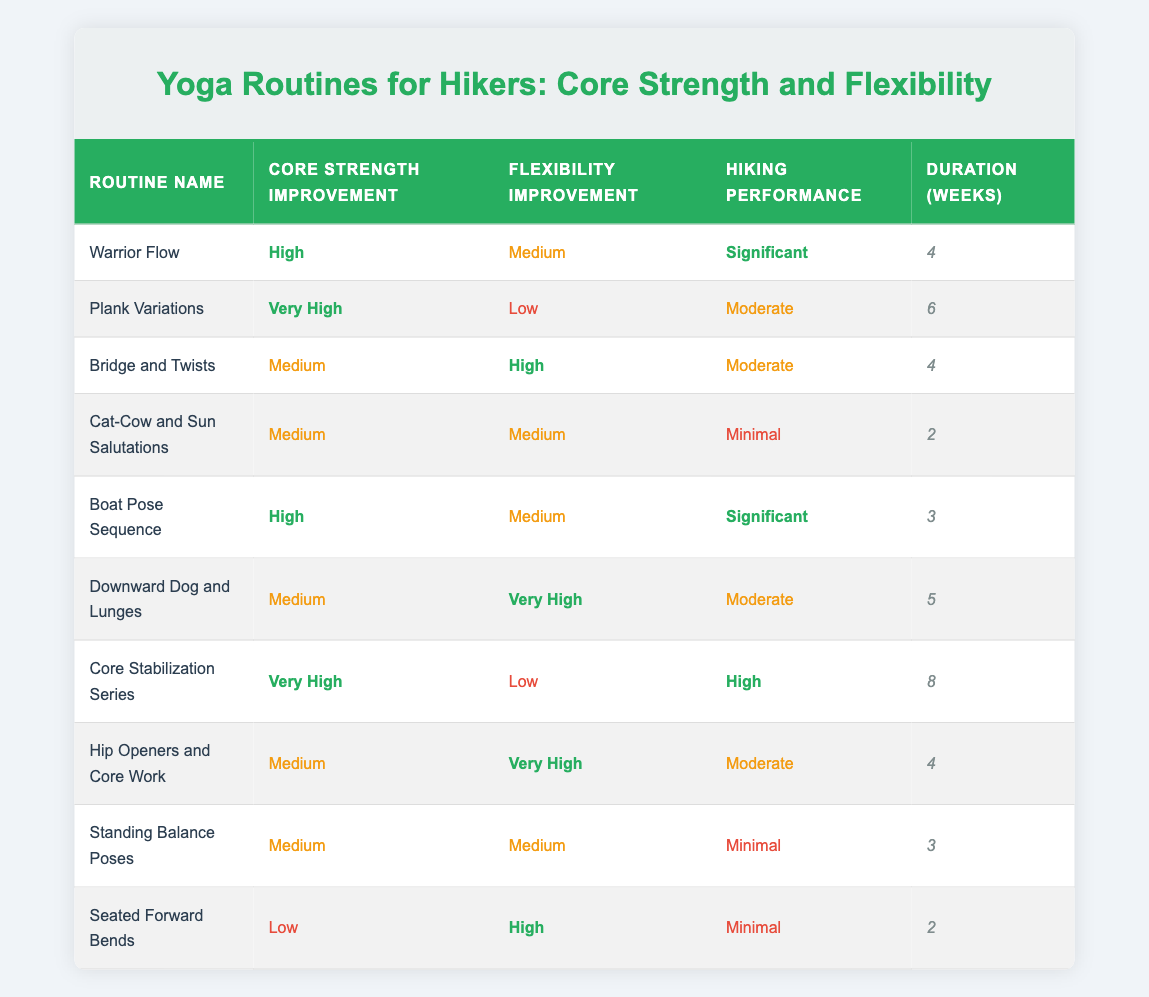What yoga routine has the highest core strength improvement? The table shows the yoga routines sorted by their core strength improvement ratings. The routine "Plank Variations" has a core strength improvement rated as "Very High," which is the highest among all routines listed.
Answer: Plank Variations How many weeks does the "Core Stabilization Series" last? The "Core Stabilization Series" routine's duration is explicitly listed in the table as 8 weeks.
Answer: 8 Is the hiking performance of "Cat-Cow and Sun Salutations" significant? Looking at the hiking performance column, "Cat-Cow and Sun Salutations" is indicated as "Minimal," meaning this routine does not lead to significant hiking performance improvements.
Answer: No Which routine offers medium flexibility improvement and high core strength improvement? By filtering the table for routines that have "Medium" flexibility improvement and "High" core strength improvement, we find "Warrior Flow" and "Boat Pose Sequence." Thus, there are two potential routines that meet these criteria.
Answer: Warrior Flow, Boat Pose Sequence What is the average duration of the yoga routines listed? To find the average duration, we sum the durations: (4 + 6 + 4 + 2 + 3 + 5 + 8 + 4 + 3 + 2) = 41 weeks. Then we divide this by the number of routines, which is 10. The average duration is 41/10 = 4.1 weeks.
Answer: 4.1 weeks Do any routines have both very high core strength improvement and very high flexibility improvement? By reviewing the table, no routine has both "Very High" in core strength improvement and "Very High" in flexibility improvement simultaneously, thus confirming there are none.
Answer: No Which routine contributes more significantly to hiking performance: "Core Stabilization Series" or "Plank Variations"? Comparing the hiking performance ratings, "Core Stabilization Series" is rated as "High," while "Plank Variations" is "Moderate." Thus, "Core Stabilization Series" contributes more significantly to hiking performance.
Answer: Core Stabilization Series How many routines take 4 weeks to complete? The table lists several routines with a duration of 4 weeks: "Warrior Flow," "Bridge and Twists," and "Hip Openers and Core Work." This totals to three routines that take 4 weeks to complete.
Answer: 3 